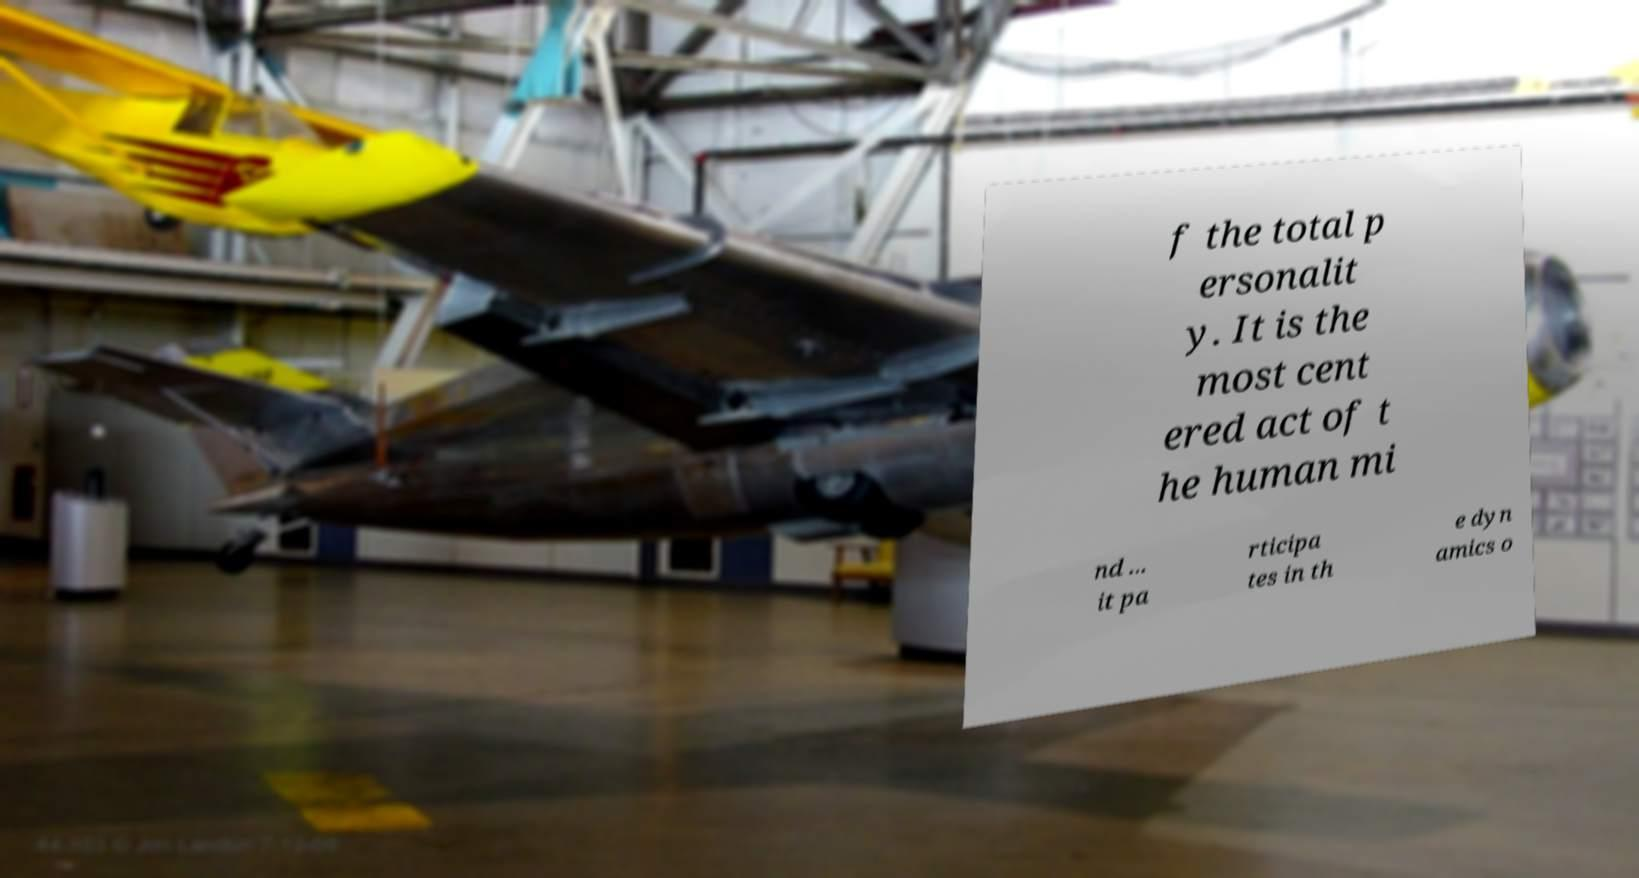What messages or text are displayed in this image? I need them in a readable, typed format. f the total p ersonalit y. It is the most cent ered act of t he human mi nd ... it pa rticipa tes in th e dyn amics o 